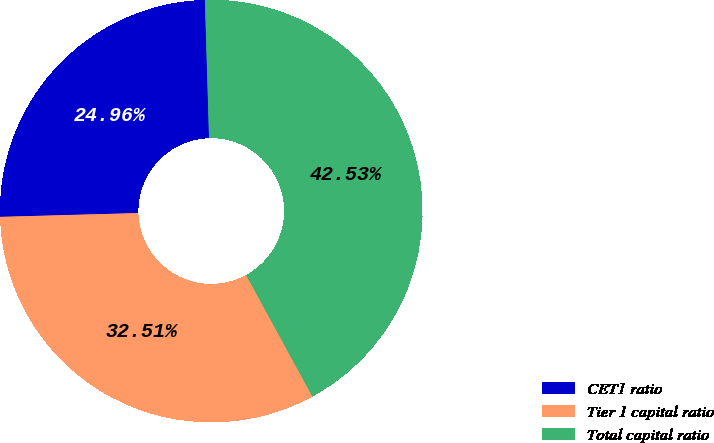<chart> <loc_0><loc_0><loc_500><loc_500><pie_chart><fcel>CET1 ratio<fcel>Tier 1 capital ratio<fcel>Total capital ratio<nl><fcel>24.96%<fcel>32.51%<fcel>42.53%<nl></chart> 